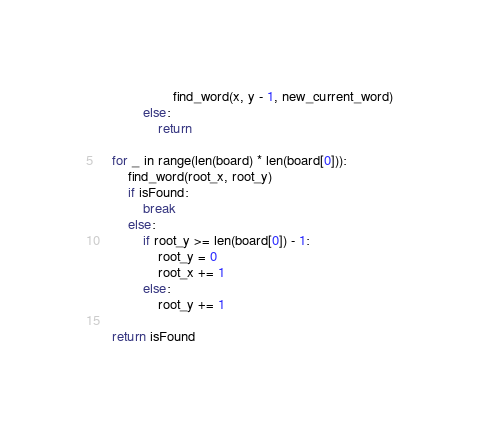<code> <loc_0><loc_0><loc_500><loc_500><_Python_>                    find_word(x, y - 1, new_current_word)
            else:
                return

    for _ in range(len(board) * len(board[0])):
        find_word(root_x, root_y)
        if isFound:
            break
        else:
            if root_y >= len(board[0]) - 1:
                root_y = 0
                root_x += 1
            else:
                root_y += 1

    return isFound
</code> 